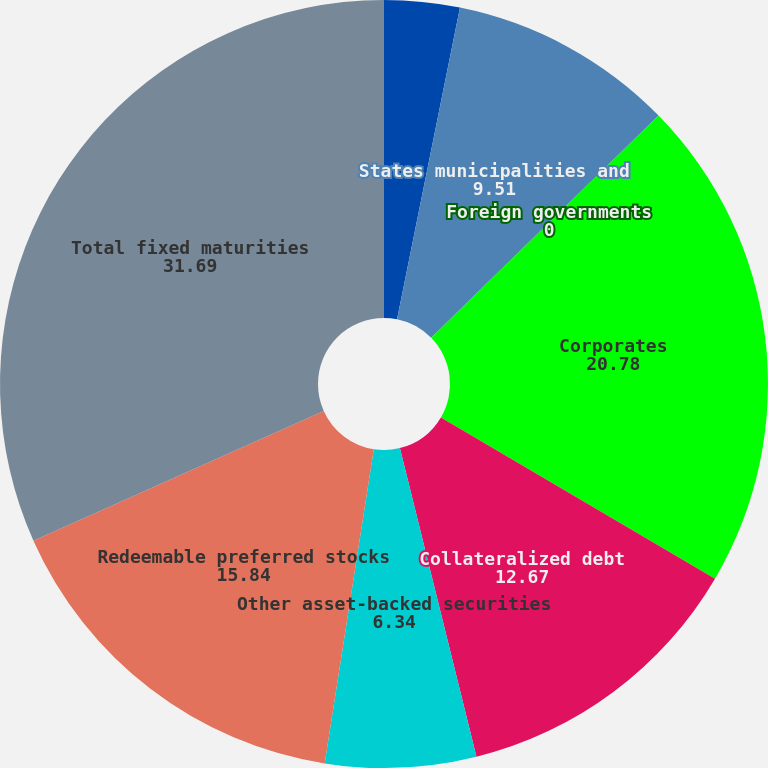<chart> <loc_0><loc_0><loc_500><loc_500><pie_chart><fcel>US Government direct<fcel>States municipalities and<fcel>Foreign governments<fcel>Corporates<fcel>Collateralized debt<fcel>Other asset-backed securities<fcel>Redeemable preferred stocks<fcel>Total fixed maturities<nl><fcel>3.17%<fcel>9.51%<fcel>0.0%<fcel>20.78%<fcel>12.67%<fcel>6.34%<fcel>15.84%<fcel>31.69%<nl></chart> 